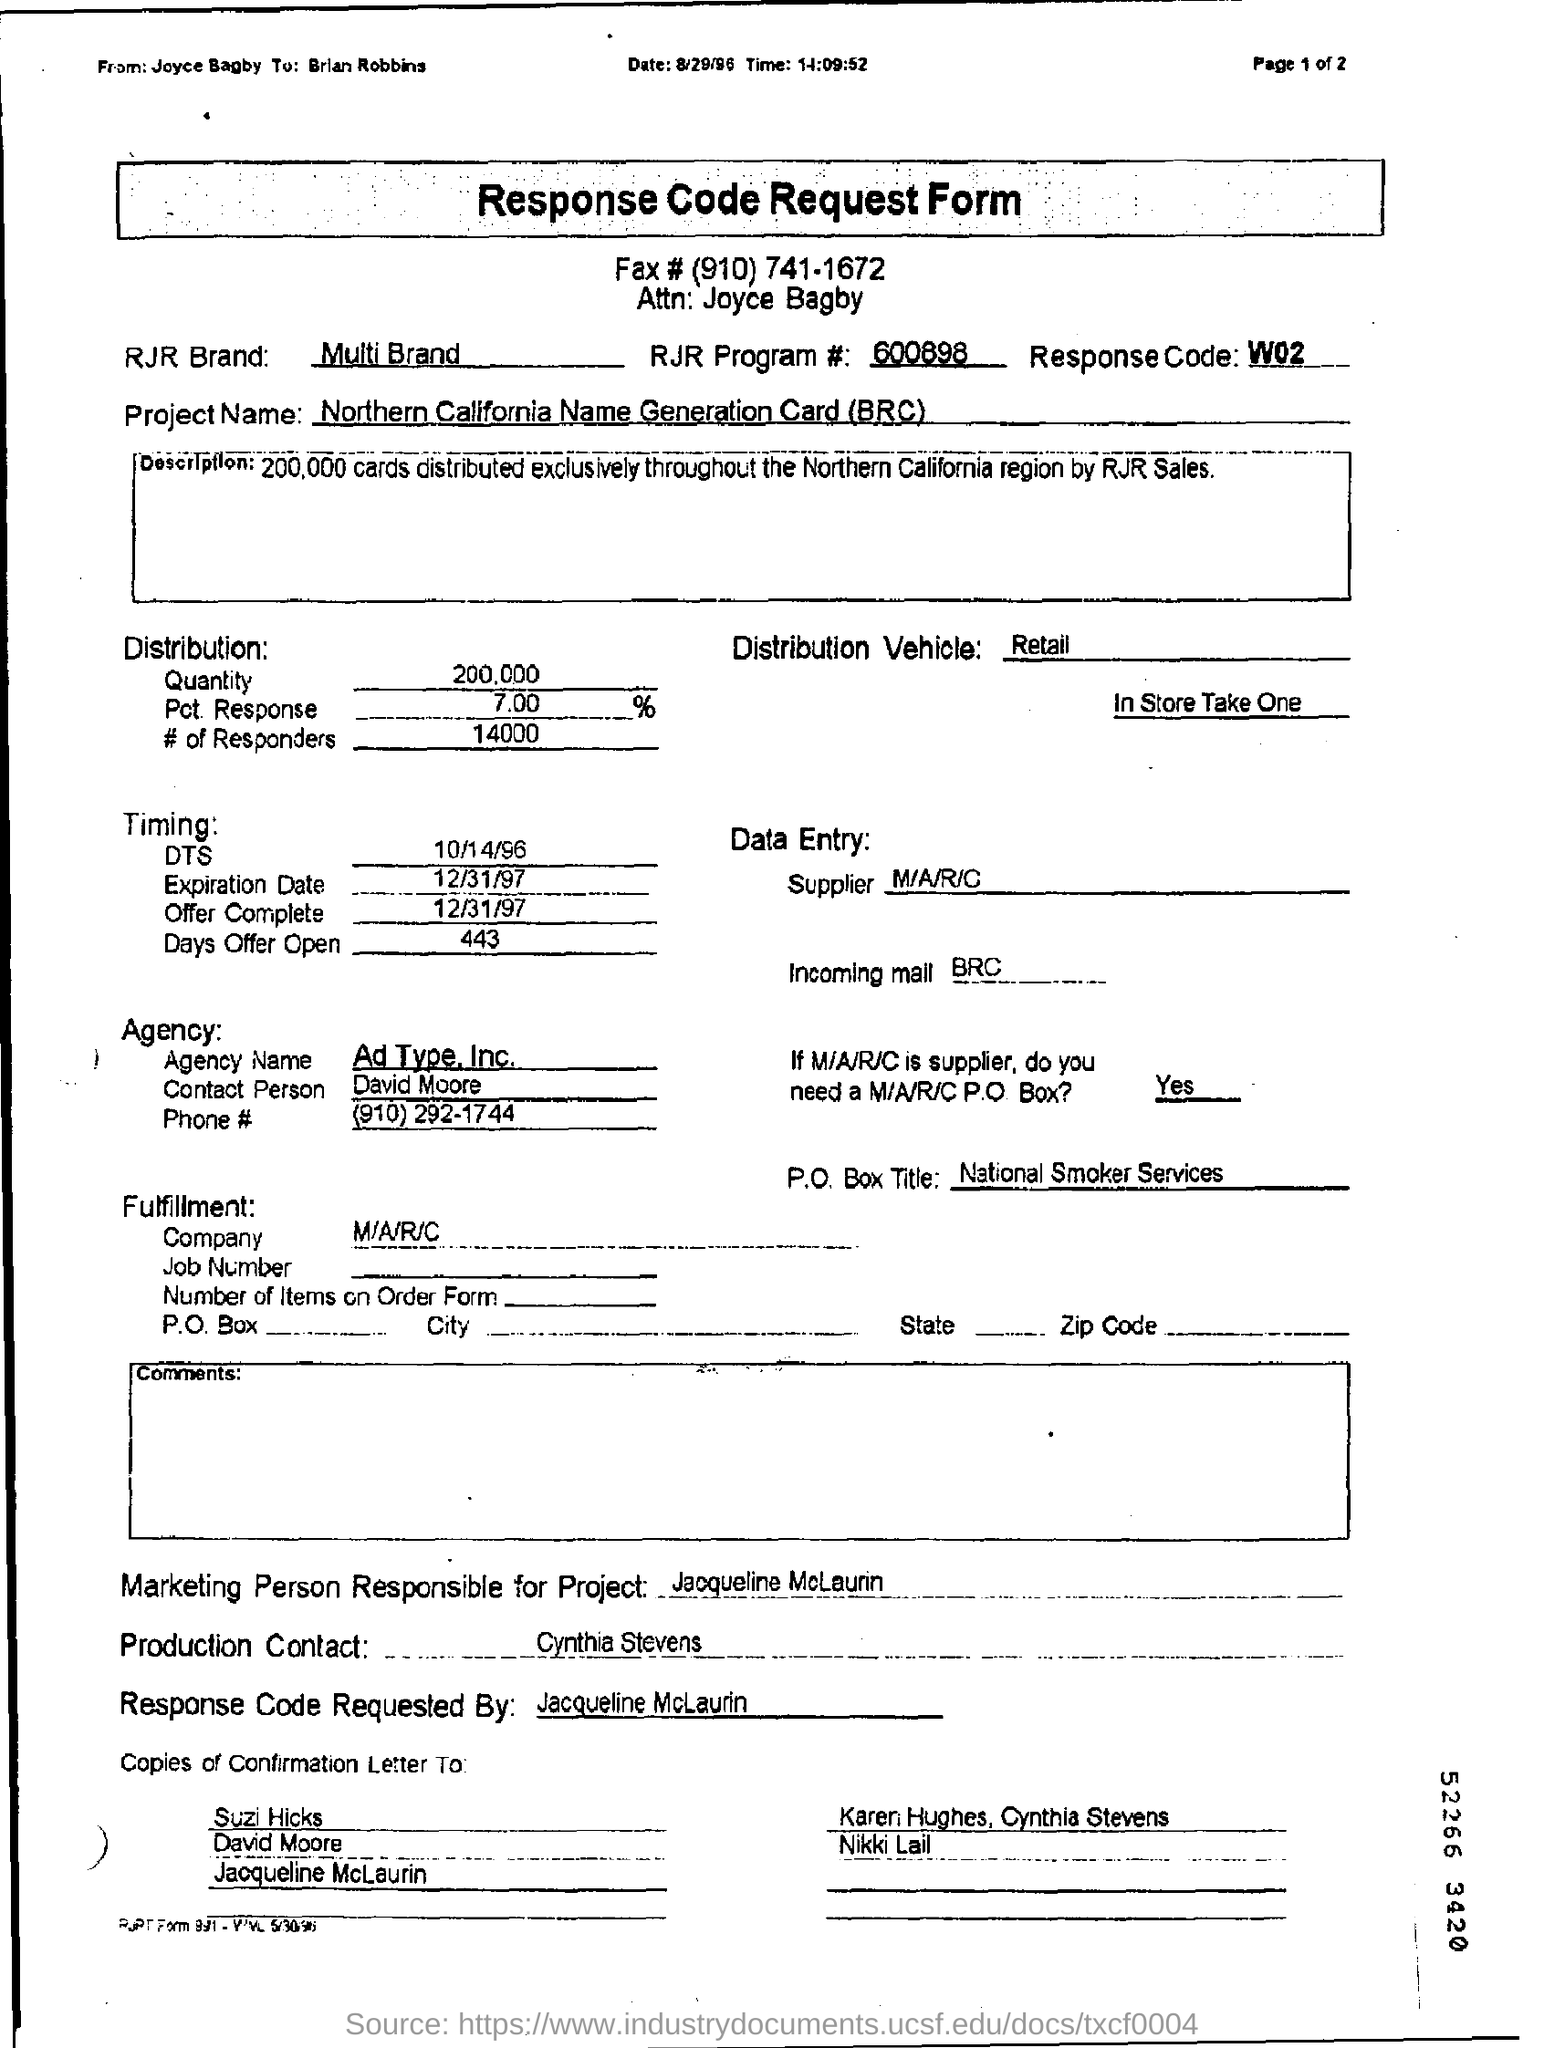Which form is this ?
Offer a terse response. Response Code Request Form. What is the project name ?
Offer a very short reply. Northern California Name Generation Card (BRC). Who is the marketing person responsible for this ?
Give a very brief answer. Jacqueline McLaurin. What is the Response code ?
Make the answer very short. W02. What is PO box title ?
Ensure brevity in your answer.  National Smoker Services. Who is the production contact?
Provide a succinct answer. Cynthia Stevens. What is RJR program number?
Make the answer very short. 600898. How many cards were distributed in the northern california region by RJR sales?
Your answer should be very brief. 200,000. 